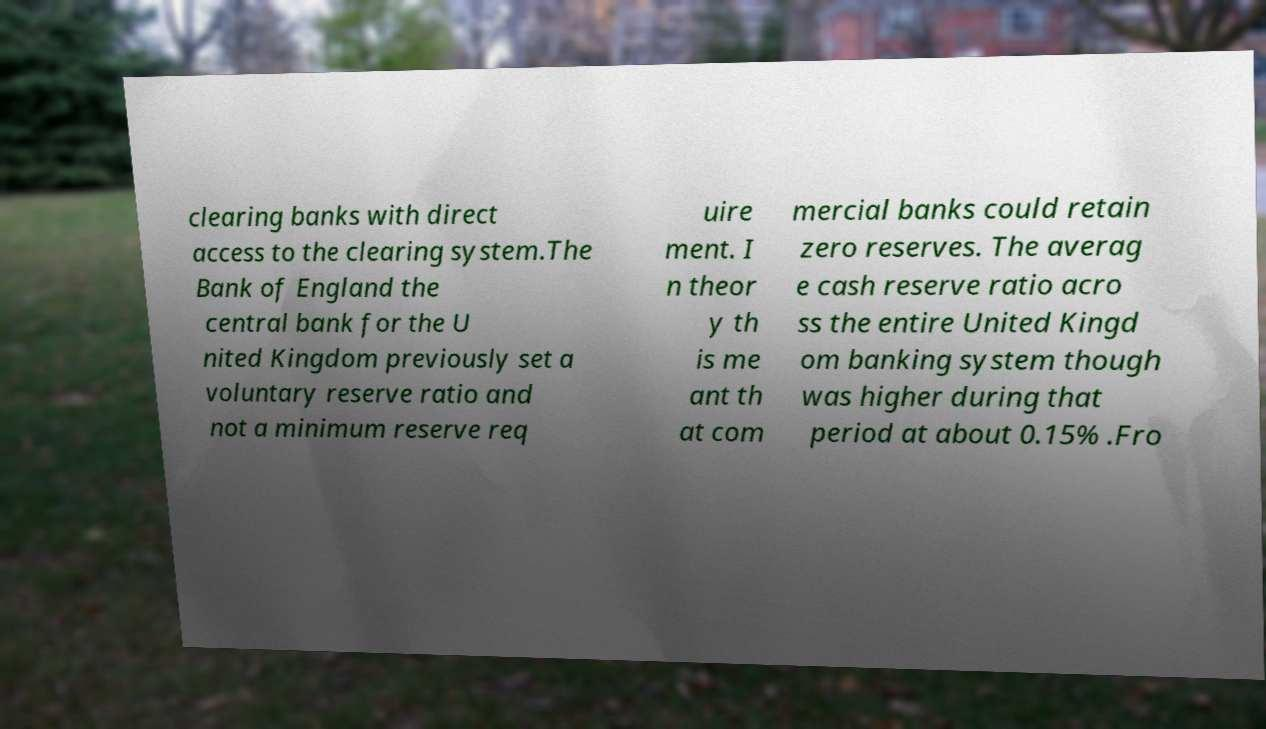Could you extract and type out the text from this image? clearing banks with direct access to the clearing system.The Bank of England the central bank for the U nited Kingdom previously set a voluntary reserve ratio and not a minimum reserve req uire ment. I n theor y th is me ant th at com mercial banks could retain zero reserves. The averag e cash reserve ratio acro ss the entire United Kingd om banking system though was higher during that period at about 0.15% .Fro 